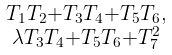<formula> <loc_0><loc_0><loc_500><loc_500>\begin{smallmatrix} T _ { 1 } T _ { 2 } + T _ { 3 } T _ { 4 } + T _ { 5 } T _ { 6 } , \\ \lambda T _ { 3 } T _ { 4 } + T _ { 5 } T _ { 6 } + T _ { 7 } ^ { 2 } \end{smallmatrix}</formula> 